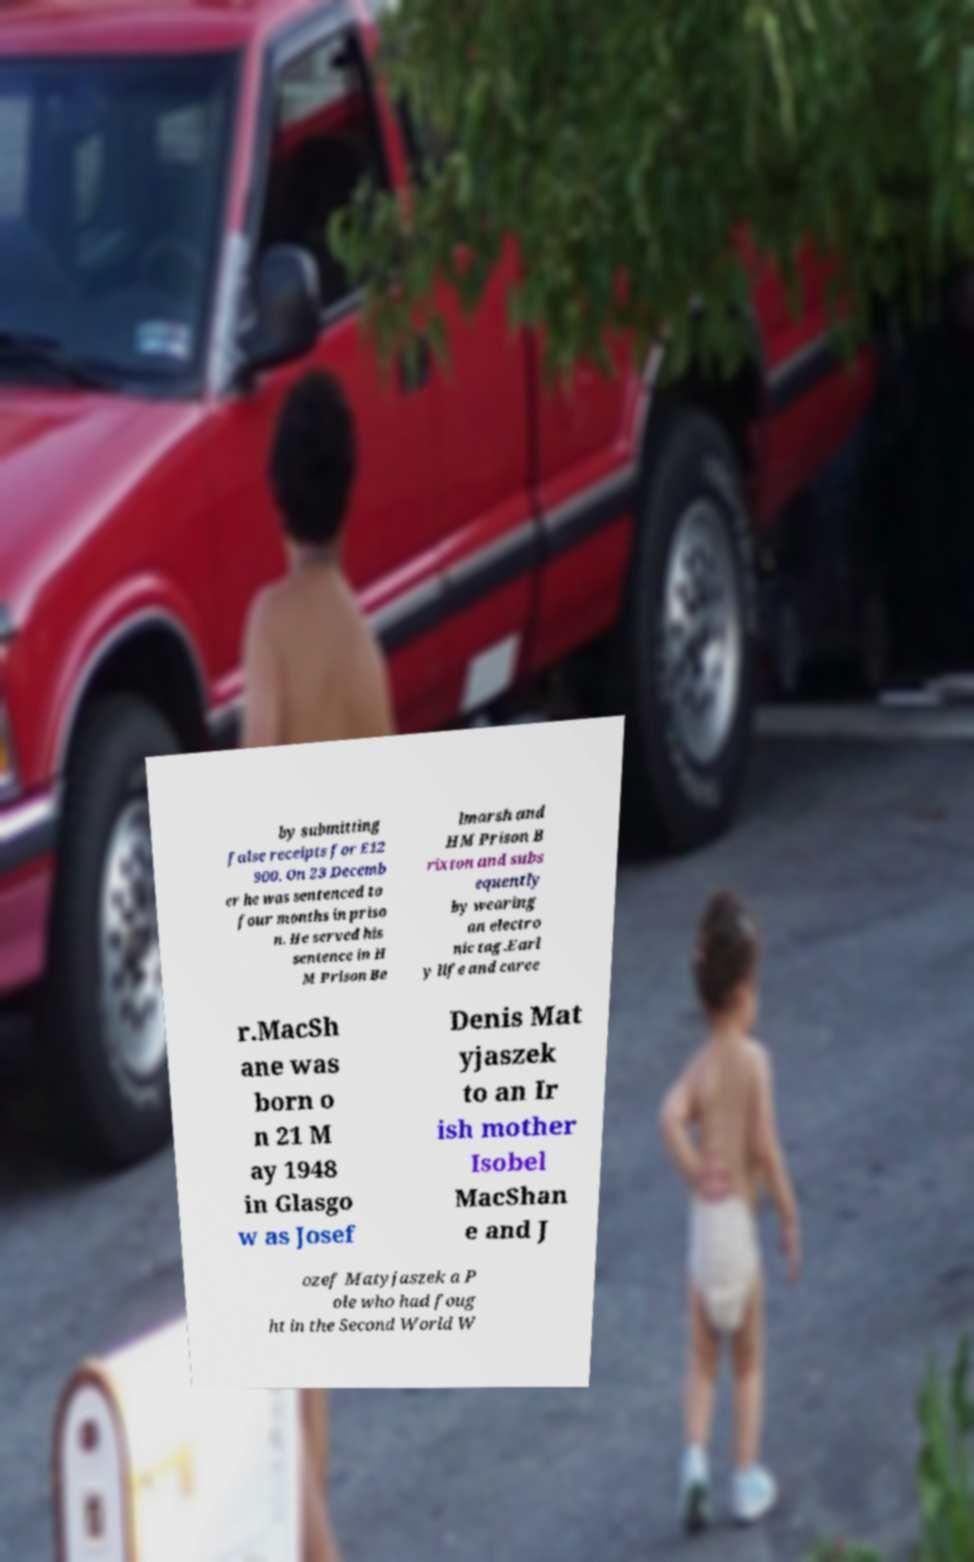Please read and relay the text visible in this image. What does it say? by submitting false receipts for £12 900. On 23 Decemb er he was sentenced to four months in priso n. He served his sentence in H M Prison Be lmarsh and HM Prison B rixton and subs equently by wearing an electro nic tag.Earl y life and caree r.MacSh ane was born o n 21 M ay 1948 in Glasgo w as Josef Denis Mat yjaszek to an Ir ish mother Isobel MacShan e and J ozef Matyjaszek a P ole who had foug ht in the Second World W 